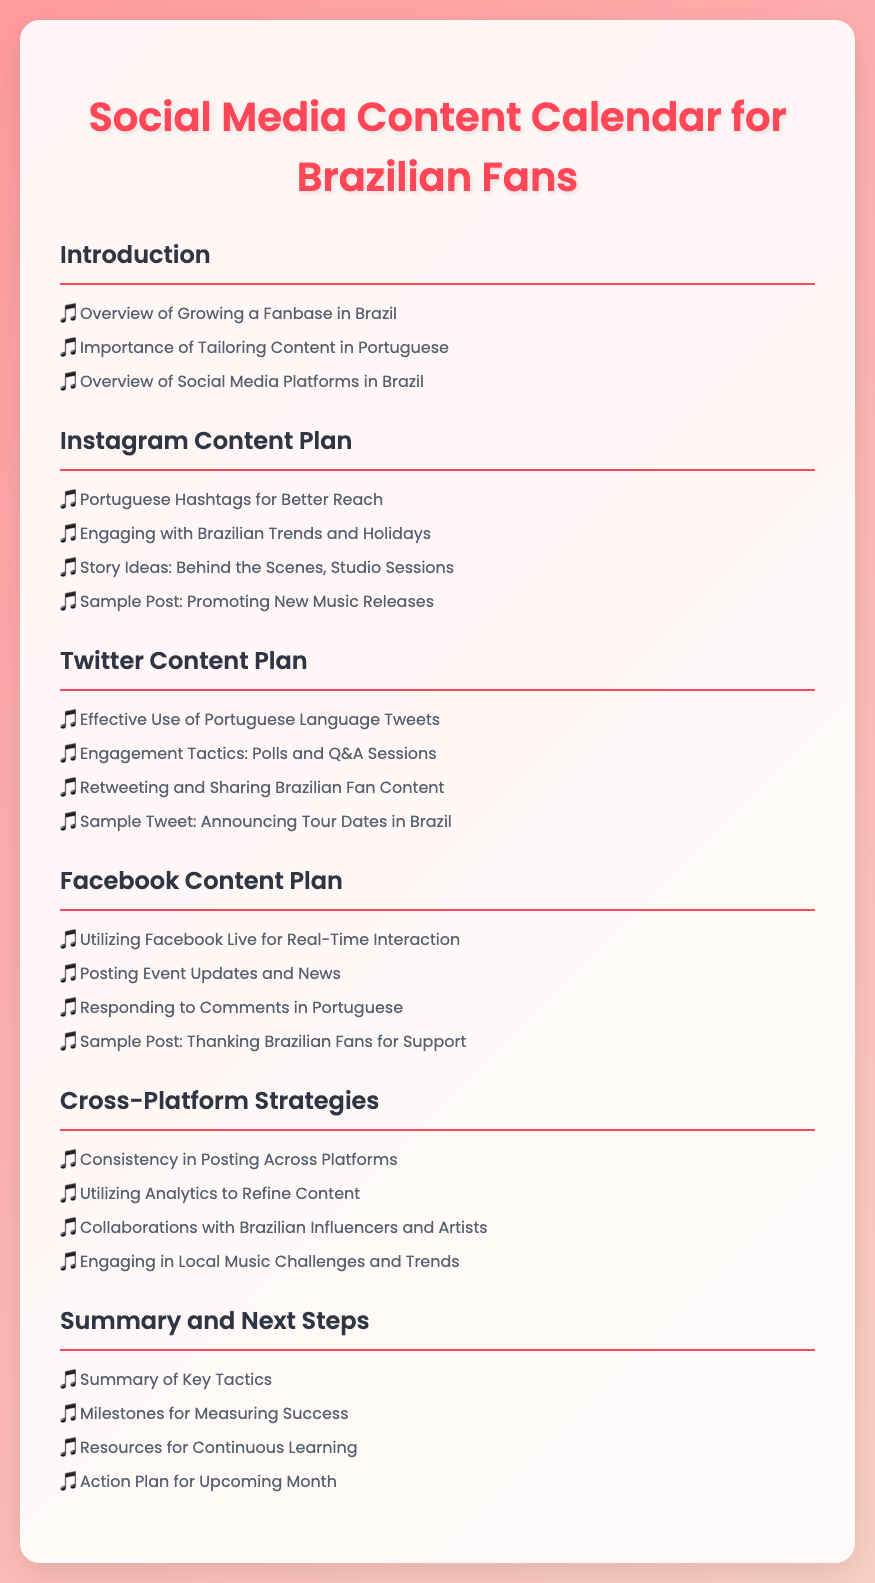Qual é o título do documento? O título do documento é a primeira coisa que aparece no cabeçalho, que descreve o conteúdo.
Answer: Social Media Content Calendar for Brazilian Fans Quantas seções principais estão no calendário de conteúdo? As seções principais são divididas e enumeradas claramente no documento.
Answer: 6 Qual é uma ideia de postagem para o planejamento do Instagram? As ideias de postagem para Instagram são listadas sob o título correspondente.
Answer: Promoting New Music Releases Qual é a estratégia mencionado para o Twitter? A estratégia para o Twitter é destacada em uma das seções e lista várias táticas.
Answer: Polls and Q&A Sessions Qual plataforma usa Facebook Live para interações em tempo real? A seção específica do Facebook explica as ferramentas disponíveis para engajar os fãs.
Answer: Facebook Quais influenciadores brasileiros devem ser considerados para colaborações? As colaborações são sugeridas em uma seção dedicada à Estratégia Cross-Platform.
Answer: Influencers and Artists Quantas ideias são listadas para o planejamento do Facebook? A seção apresenta um número específico de ideias para melhorar a interação no Facebook.
Answer: 4 Qual é o objetivo principal do resumo e do plano de ação? O resumo e o plano de ação ajudam a revisar e organizar as etapas a seguir, definidos claramente no documento.
Answer: Measuring Success 